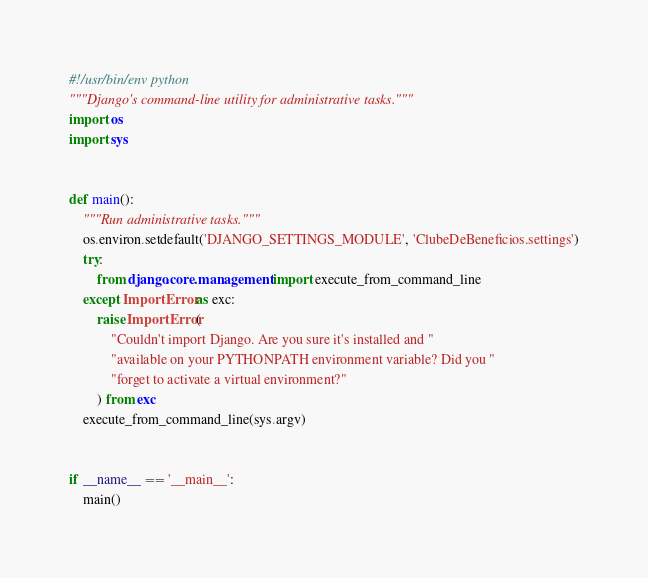Convert code to text. <code><loc_0><loc_0><loc_500><loc_500><_Python_>#!/usr/bin/env python
"""Django's command-line utility for administrative tasks."""
import os
import sys


def main():
    """Run administrative tasks."""
    os.environ.setdefault('DJANGO_SETTINGS_MODULE', 'ClubeDeBeneficios.settings')
    try:
        from django.core.management import execute_from_command_line
    except ImportError as exc:
        raise ImportError(
            "Couldn't import Django. Are you sure it's installed and "
            "available on your PYTHONPATH environment variable? Did you "
            "forget to activate a virtual environment?"
        ) from exc
    execute_from_command_line(sys.argv)


if __name__ == '__main__':
    main()
</code> 